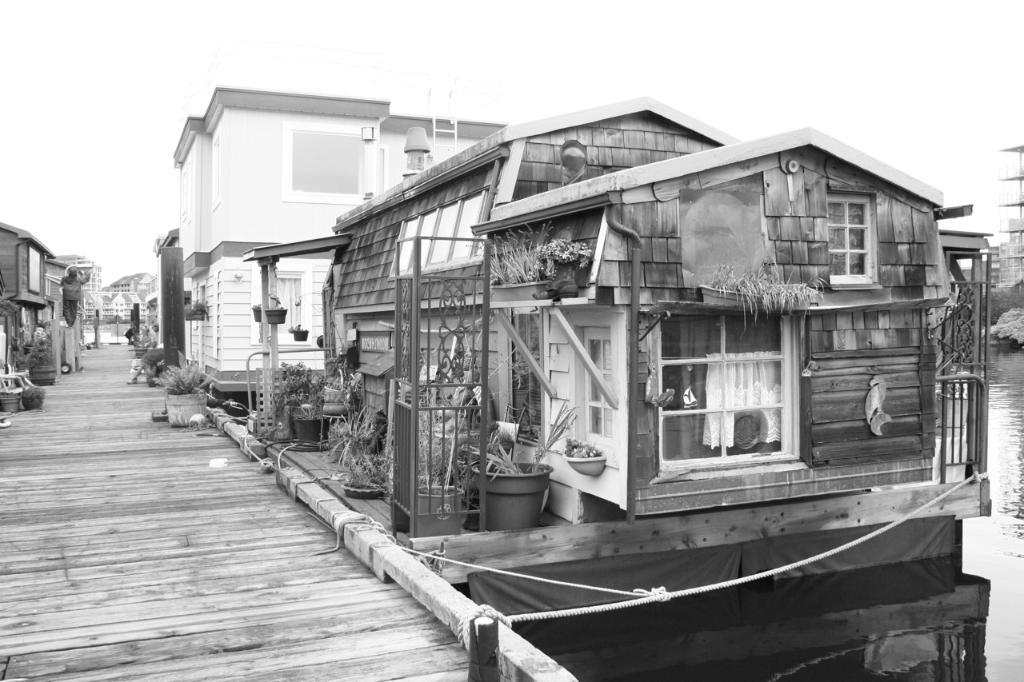What is located in the middle of the image? There are plants and buildings in the middle of the image. What can be seen behind the plants and buildings? There is water visible behind the plants and buildings. What is visible at the top of the image? The sky is visible at the top of the image. What type of song can be heard coming from the buildings in the image? There is no indication of any sound, including a song, in the image. 